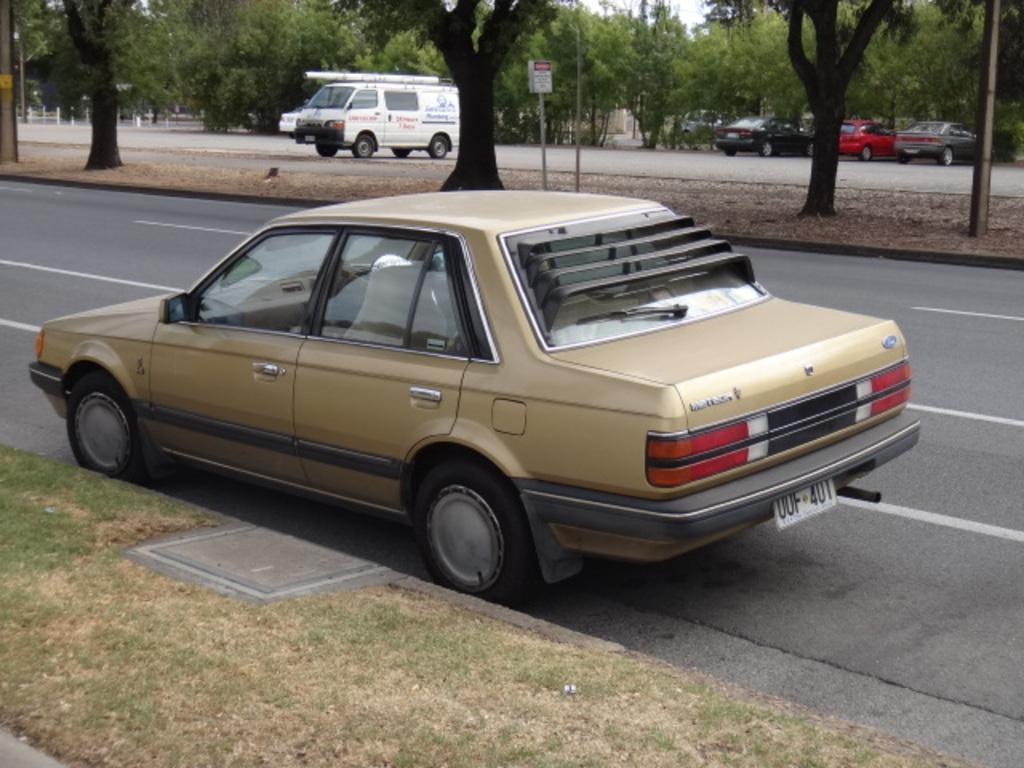In one or two sentences, can you explain what this image depicts? In the image there is a car in the foreground and around that there are trees and other vehicles. 